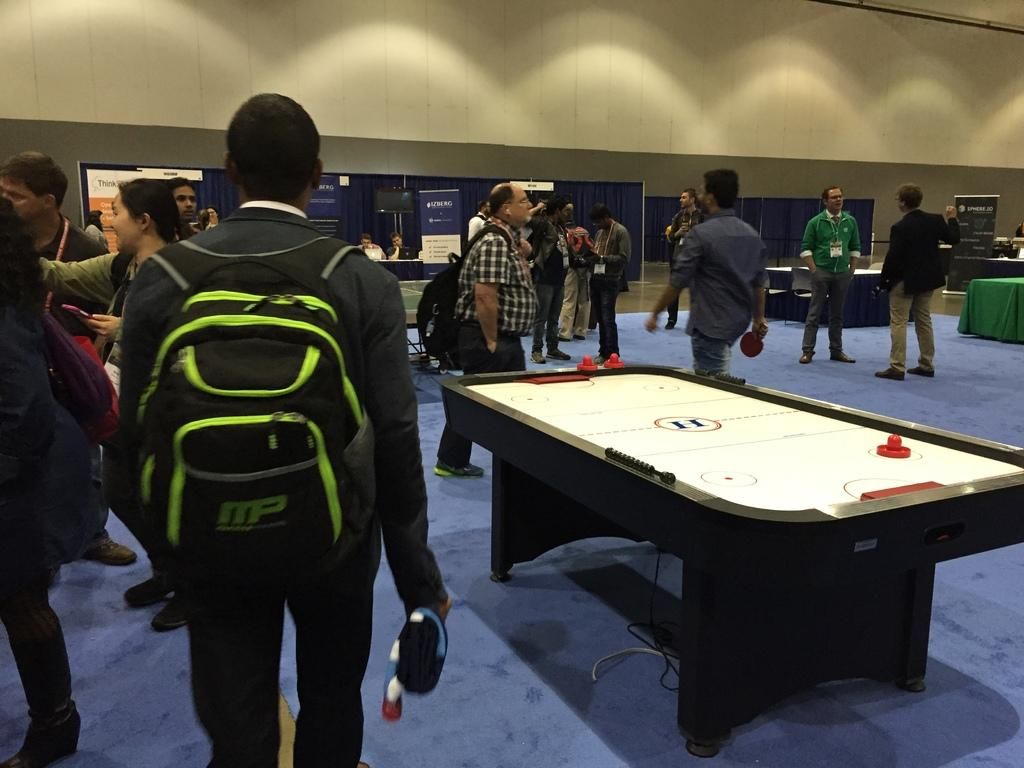What are the people in the image doing? The people in the image are on the floor in the room. What can be seen in the background of the image? There are hoardings and indoor gaming boards in the background of the image. What grade of foot is being used by the people in the image? There is no mention of feet or grades in the image, so this question cannot be answered. 